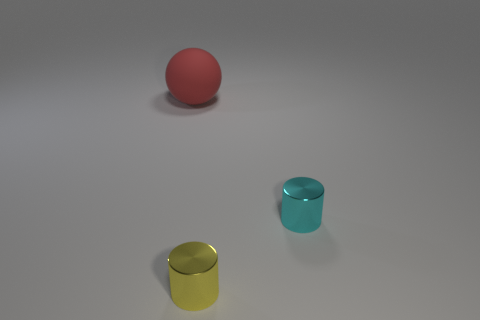Add 3 tiny yellow metallic cylinders. How many objects exist? 6 Subtract all spheres. How many objects are left? 2 Subtract all balls. Subtract all small yellow cylinders. How many objects are left? 1 Add 3 tiny cyan things. How many tiny cyan things are left? 4 Add 3 tiny cylinders. How many tiny cylinders exist? 5 Subtract 1 cyan cylinders. How many objects are left? 2 